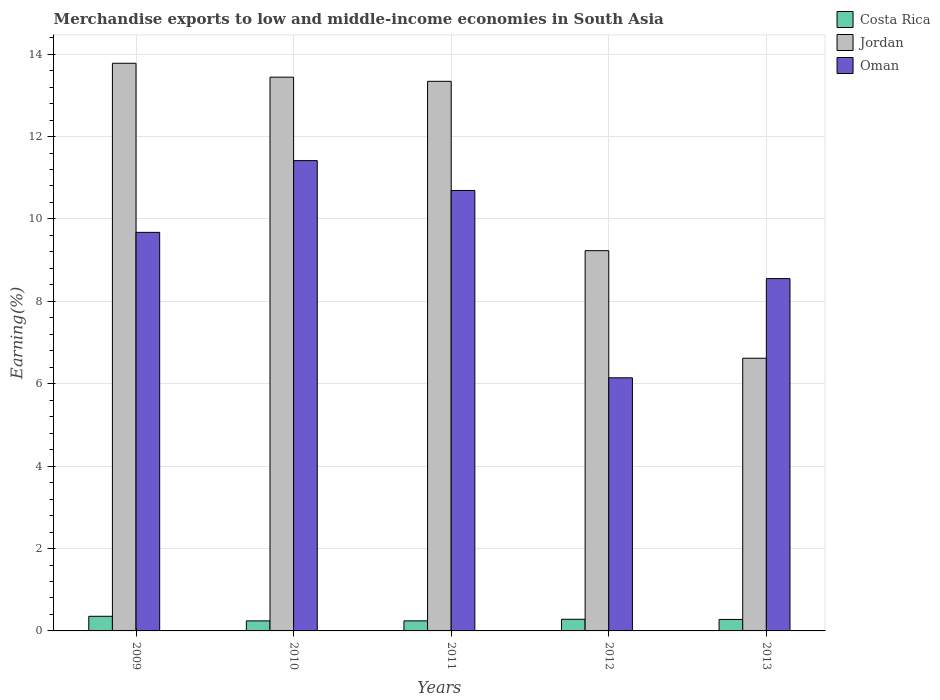How many groups of bars are there?
Provide a short and direct response. 5. Are the number of bars per tick equal to the number of legend labels?
Ensure brevity in your answer.  Yes. How many bars are there on the 1st tick from the left?
Your response must be concise. 3. What is the label of the 4th group of bars from the left?
Make the answer very short. 2012. What is the percentage of amount earned from merchandise exports in Jordan in 2010?
Provide a short and direct response. 13.44. Across all years, what is the maximum percentage of amount earned from merchandise exports in Jordan?
Keep it short and to the point. 13.78. Across all years, what is the minimum percentage of amount earned from merchandise exports in Jordan?
Ensure brevity in your answer.  6.62. In which year was the percentage of amount earned from merchandise exports in Jordan minimum?
Provide a succinct answer. 2013. What is the total percentage of amount earned from merchandise exports in Costa Rica in the graph?
Offer a very short reply. 1.4. What is the difference between the percentage of amount earned from merchandise exports in Oman in 2009 and that in 2012?
Provide a short and direct response. 3.53. What is the difference between the percentage of amount earned from merchandise exports in Oman in 2012 and the percentage of amount earned from merchandise exports in Costa Rica in 2013?
Your answer should be compact. 5.87. What is the average percentage of amount earned from merchandise exports in Jordan per year?
Give a very brief answer. 11.28. In the year 2009, what is the difference between the percentage of amount earned from merchandise exports in Costa Rica and percentage of amount earned from merchandise exports in Jordan?
Give a very brief answer. -13.42. In how many years, is the percentage of amount earned from merchandise exports in Jordan greater than 8.8 %?
Your answer should be compact. 4. What is the ratio of the percentage of amount earned from merchandise exports in Costa Rica in 2010 to that in 2012?
Provide a succinct answer. 0.86. Is the difference between the percentage of amount earned from merchandise exports in Costa Rica in 2009 and 2012 greater than the difference between the percentage of amount earned from merchandise exports in Jordan in 2009 and 2012?
Provide a succinct answer. No. What is the difference between the highest and the second highest percentage of amount earned from merchandise exports in Costa Rica?
Offer a terse response. 0.07. What is the difference between the highest and the lowest percentage of amount earned from merchandise exports in Oman?
Your answer should be very brief. 5.27. What does the 2nd bar from the left in 2012 represents?
Your answer should be compact. Jordan. What does the 2nd bar from the right in 2010 represents?
Your answer should be very brief. Jordan. Are all the bars in the graph horizontal?
Provide a short and direct response. No. How many years are there in the graph?
Keep it short and to the point. 5. Are the values on the major ticks of Y-axis written in scientific E-notation?
Your answer should be very brief. No. Does the graph contain any zero values?
Make the answer very short. No. How many legend labels are there?
Keep it short and to the point. 3. How are the legend labels stacked?
Your answer should be very brief. Vertical. What is the title of the graph?
Offer a very short reply. Merchandise exports to low and middle-income economies in South Asia. What is the label or title of the X-axis?
Your answer should be compact. Years. What is the label or title of the Y-axis?
Ensure brevity in your answer.  Earning(%). What is the Earning(%) of Costa Rica in 2009?
Provide a short and direct response. 0.36. What is the Earning(%) of Jordan in 2009?
Offer a terse response. 13.78. What is the Earning(%) in Oman in 2009?
Your answer should be compact. 9.67. What is the Earning(%) in Costa Rica in 2010?
Offer a very short reply. 0.24. What is the Earning(%) in Jordan in 2010?
Your answer should be compact. 13.44. What is the Earning(%) of Oman in 2010?
Give a very brief answer. 11.42. What is the Earning(%) of Costa Rica in 2011?
Offer a terse response. 0.24. What is the Earning(%) of Jordan in 2011?
Your response must be concise. 13.34. What is the Earning(%) of Oman in 2011?
Offer a very short reply. 10.69. What is the Earning(%) in Costa Rica in 2012?
Offer a very short reply. 0.28. What is the Earning(%) in Jordan in 2012?
Ensure brevity in your answer.  9.23. What is the Earning(%) in Oman in 2012?
Your answer should be very brief. 6.14. What is the Earning(%) in Costa Rica in 2013?
Keep it short and to the point. 0.28. What is the Earning(%) of Jordan in 2013?
Keep it short and to the point. 6.62. What is the Earning(%) in Oman in 2013?
Give a very brief answer. 8.55. Across all years, what is the maximum Earning(%) of Costa Rica?
Keep it short and to the point. 0.36. Across all years, what is the maximum Earning(%) of Jordan?
Your answer should be compact. 13.78. Across all years, what is the maximum Earning(%) of Oman?
Your answer should be very brief. 11.42. Across all years, what is the minimum Earning(%) of Costa Rica?
Your answer should be very brief. 0.24. Across all years, what is the minimum Earning(%) in Jordan?
Offer a terse response. 6.62. Across all years, what is the minimum Earning(%) in Oman?
Your answer should be very brief. 6.14. What is the total Earning(%) in Costa Rica in the graph?
Make the answer very short. 1.4. What is the total Earning(%) in Jordan in the graph?
Ensure brevity in your answer.  56.41. What is the total Earning(%) in Oman in the graph?
Your answer should be very brief. 46.48. What is the difference between the Earning(%) of Costa Rica in 2009 and that in 2010?
Provide a succinct answer. 0.11. What is the difference between the Earning(%) in Jordan in 2009 and that in 2010?
Your response must be concise. 0.34. What is the difference between the Earning(%) of Oman in 2009 and that in 2010?
Your answer should be very brief. -1.74. What is the difference between the Earning(%) of Costa Rica in 2009 and that in 2011?
Your answer should be compact. 0.11. What is the difference between the Earning(%) in Jordan in 2009 and that in 2011?
Keep it short and to the point. 0.44. What is the difference between the Earning(%) of Oman in 2009 and that in 2011?
Your answer should be compact. -1.02. What is the difference between the Earning(%) of Costa Rica in 2009 and that in 2012?
Your answer should be very brief. 0.07. What is the difference between the Earning(%) in Jordan in 2009 and that in 2012?
Give a very brief answer. 4.55. What is the difference between the Earning(%) of Oman in 2009 and that in 2012?
Your response must be concise. 3.53. What is the difference between the Earning(%) of Costa Rica in 2009 and that in 2013?
Ensure brevity in your answer.  0.08. What is the difference between the Earning(%) of Jordan in 2009 and that in 2013?
Offer a very short reply. 7.16. What is the difference between the Earning(%) in Oman in 2009 and that in 2013?
Offer a very short reply. 1.12. What is the difference between the Earning(%) of Costa Rica in 2010 and that in 2011?
Make the answer very short. -0. What is the difference between the Earning(%) in Jordan in 2010 and that in 2011?
Your answer should be very brief. 0.1. What is the difference between the Earning(%) in Oman in 2010 and that in 2011?
Make the answer very short. 0.72. What is the difference between the Earning(%) in Costa Rica in 2010 and that in 2012?
Provide a short and direct response. -0.04. What is the difference between the Earning(%) in Jordan in 2010 and that in 2012?
Keep it short and to the point. 4.21. What is the difference between the Earning(%) of Oman in 2010 and that in 2012?
Give a very brief answer. 5.27. What is the difference between the Earning(%) of Costa Rica in 2010 and that in 2013?
Your answer should be compact. -0.04. What is the difference between the Earning(%) of Jordan in 2010 and that in 2013?
Make the answer very short. 6.82. What is the difference between the Earning(%) in Oman in 2010 and that in 2013?
Your response must be concise. 2.86. What is the difference between the Earning(%) of Costa Rica in 2011 and that in 2012?
Provide a short and direct response. -0.04. What is the difference between the Earning(%) of Jordan in 2011 and that in 2012?
Make the answer very short. 4.11. What is the difference between the Earning(%) of Oman in 2011 and that in 2012?
Provide a succinct answer. 4.55. What is the difference between the Earning(%) in Costa Rica in 2011 and that in 2013?
Give a very brief answer. -0.03. What is the difference between the Earning(%) of Jordan in 2011 and that in 2013?
Give a very brief answer. 6.72. What is the difference between the Earning(%) in Oman in 2011 and that in 2013?
Provide a succinct answer. 2.14. What is the difference between the Earning(%) in Costa Rica in 2012 and that in 2013?
Offer a terse response. 0. What is the difference between the Earning(%) in Jordan in 2012 and that in 2013?
Keep it short and to the point. 2.61. What is the difference between the Earning(%) of Oman in 2012 and that in 2013?
Give a very brief answer. -2.41. What is the difference between the Earning(%) in Costa Rica in 2009 and the Earning(%) in Jordan in 2010?
Your answer should be very brief. -13.09. What is the difference between the Earning(%) of Costa Rica in 2009 and the Earning(%) of Oman in 2010?
Make the answer very short. -11.06. What is the difference between the Earning(%) in Jordan in 2009 and the Earning(%) in Oman in 2010?
Your response must be concise. 2.36. What is the difference between the Earning(%) of Costa Rica in 2009 and the Earning(%) of Jordan in 2011?
Make the answer very short. -12.99. What is the difference between the Earning(%) of Costa Rica in 2009 and the Earning(%) of Oman in 2011?
Give a very brief answer. -10.34. What is the difference between the Earning(%) of Jordan in 2009 and the Earning(%) of Oman in 2011?
Offer a terse response. 3.09. What is the difference between the Earning(%) of Costa Rica in 2009 and the Earning(%) of Jordan in 2012?
Provide a short and direct response. -8.87. What is the difference between the Earning(%) of Costa Rica in 2009 and the Earning(%) of Oman in 2012?
Ensure brevity in your answer.  -5.79. What is the difference between the Earning(%) in Jordan in 2009 and the Earning(%) in Oman in 2012?
Give a very brief answer. 7.64. What is the difference between the Earning(%) of Costa Rica in 2009 and the Earning(%) of Jordan in 2013?
Ensure brevity in your answer.  -6.26. What is the difference between the Earning(%) in Costa Rica in 2009 and the Earning(%) in Oman in 2013?
Give a very brief answer. -8.2. What is the difference between the Earning(%) in Jordan in 2009 and the Earning(%) in Oman in 2013?
Provide a succinct answer. 5.23. What is the difference between the Earning(%) in Costa Rica in 2010 and the Earning(%) in Jordan in 2011?
Ensure brevity in your answer.  -13.1. What is the difference between the Earning(%) in Costa Rica in 2010 and the Earning(%) in Oman in 2011?
Your response must be concise. -10.45. What is the difference between the Earning(%) in Jordan in 2010 and the Earning(%) in Oman in 2011?
Your answer should be compact. 2.75. What is the difference between the Earning(%) of Costa Rica in 2010 and the Earning(%) of Jordan in 2012?
Your answer should be compact. -8.99. What is the difference between the Earning(%) of Costa Rica in 2010 and the Earning(%) of Oman in 2012?
Give a very brief answer. -5.9. What is the difference between the Earning(%) of Jordan in 2010 and the Earning(%) of Oman in 2012?
Your answer should be compact. 7.3. What is the difference between the Earning(%) of Costa Rica in 2010 and the Earning(%) of Jordan in 2013?
Provide a short and direct response. -6.38. What is the difference between the Earning(%) in Costa Rica in 2010 and the Earning(%) in Oman in 2013?
Give a very brief answer. -8.31. What is the difference between the Earning(%) of Jordan in 2010 and the Earning(%) of Oman in 2013?
Your answer should be compact. 4.89. What is the difference between the Earning(%) in Costa Rica in 2011 and the Earning(%) in Jordan in 2012?
Offer a terse response. -8.99. What is the difference between the Earning(%) of Costa Rica in 2011 and the Earning(%) of Oman in 2012?
Ensure brevity in your answer.  -5.9. What is the difference between the Earning(%) in Jordan in 2011 and the Earning(%) in Oman in 2012?
Provide a succinct answer. 7.2. What is the difference between the Earning(%) in Costa Rica in 2011 and the Earning(%) in Jordan in 2013?
Offer a terse response. -6.38. What is the difference between the Earning(%) of Costa Rica in 2011 and the Earning(%) of Oman in 2013?
Keep it short and to the point. -8.31. What is the difference between the Earning(%) in Jordan in 2011 and the Earning(%) in Oman in 2013?
Provide a short and direct response. 4.79. What is the difference between the Earning(%) of Costa Rica in 2012 and the Earning(%) of Jordan in 2013?
Give a very brief answer. -6.34. What is the difference between the Earning(%) in Costa Rica in 2012 and the Earning(%) in Oman in 2013?
Provide a short and direct response. -8.27. What is the difference between the Earning(%) of Jordan in 2012 and the Earning(%) of Oman in 2013?
Your response must be concise. 0.68. What is the average Earning(%) of Costa Rica per year?
Make the answer very short. 0.28. What is the average Earning(%) in Jordan per year?
Provide a short and direct response. 11.28. What is the average Earning(%) of Oman per year?
Provide a succinct answer. 9.3. In the year 2009, what is the difference between the Earning(%) of Costa Rica and Earning(%) of Jordan?
Your answer should be very brief. -13.42. In the year 2009, what is the difference between the Earning(%) in Costa Rica and Earning(%) in Oman?
Keep it short and to the point. -9.32. In the year 2009, what is the difference between the Earning(%) of Jordan and Earning(%) of Oman?
Your response must be concise. 4.1. In the year 2010, what is the difference between the Earning(%) of Costa Rica and Earning(%) of Jordan?
Ensure brevity in your answer.  -13.2. In the year 2010, what is the difference between the Earning(%) in Costa Rica and Earning(%) in Oman?
Make the answer very short. -11.17. In the year 2010, what is the difference between the Earning(%) in Jordan and Earning(%) in Oman?
Offer a terse response. 2.03. In the year 2011, what is the difference between the Earning(%) in Costa Rica and Earning(%) in Jordan?
Offer a terse response. -13.1. In the year 2011, what is the difference between the Earning(%) in Costa Rica and Earning(%) in Oman?
Your answer should be compact. -10.45. In the year 2011, what is the difference between the Earning(%) in Jordan and Earning(%) in Oman?
Offer a terse response. 2.65. In the year 2012, what is the difference between the Earning(%) in Costa Rica and Earning(%) in Jordan?
Give a very brief answer. -8.95. In the year 2012, what is the difference between the Earning(%) of Costa Rica and Earning(%) of Oman?
Your answer should be compact. -5.86. In the year 2012, what is the difference between the Earning(%) in Jordan and Earning(%) in Oman?
Keep it short and to the point. 3.09. In the year 2013, what is the difference between the Earning(%) in Costa Rica and Earning(%) in Jordan?
Your response must be concise. -6.34. In the year 2013, what is the difference between the Earning(%) in Costa Rica and Earning(%) in Oman?
Your answer should be very brief. -8.27. In the year 2013, what is the difference between the Earning(%) of Jordan and Earning(%) of Oman?
Your answer should be compact. -1.93. What is the ratio of the Earning(%) in Costa Rica in 2009 to that in 2010?
Offer a very short reply. 1.46. What is the ratio of the Earning(%) of Jordan in 2009 to that in 2010?
Offer a very short reply. 1.03. What is the ratio of the Earning(%) of Oman in 2009 to that in 2010?
Your answer should be very brief. 0.85. What is the ratio of the Earning(%) in Costa Rica in 2009 to that in 2011?
Make the answer very short. 1.46. What is the ratio of the Earning(%) in Jordan in 2009 to that in 2011?
Your answer should be compact. 1.03. What is the ratio of the Earning(%) of Oman in 2009 to that in 2011?
Offer a terse response. 0.9. What is the ratio of the Earning(%) in Costa Rica in 2009 to that in 2012?
Offer a very short reply. 1.26. What is the ratio of the Earning(%) of Jordan in 2009 to that in 2012?
Offer a very short reply. 1.49. What is the ratio of the Earning(%) of Oman in 2009 to that in 2012?
Keep it short and to the point. 1.57. What is the ratio of the Earning(%) of Costa Rica in 2009 to that in 2013?
Your answer should be compact. 1.28. What is the ratio of the Earning(%) of Jordan in 2009 to that in 2013?
Your response must be concise. 2.08. What is the ratio of the Earning(%) in Oman in 2009 to that in 2013?
Provide a succinct answer. 1.13. What is the ratio of the Earning(%) in Costa Rica in 2010 to that in 2011?
Your answer should be very brief. 1. What is the ratio of the Earning(%) in Jordan in 2010 to that in 2011?
Provide a succinct answer. 1.01. What is the ratio of the Earning(%) of Oman in 2010 to that in 2011?
Offer a terse response. 1.07. What is the ratio of the Earning(%) of Costa Rica in 2010 to that in 2012?
Offer a terse response. 0.86. What is the ratio of the Earning(%) of Jordan in 2010 to that in 2012?
Provide a short and direct response. 1.46. What is the ratio of the Earning(%) in Oman in 2010 to that in 2012?
Your answer should be compact. 1.86. What is the ratio of the Earning(%) in Costa Rica in 2010 to that in 2013?
Make the answer very short. 0.87. What is the ratio of the Earning(%) in Jordan in 2010 to that in 2013?
Give a very brief answer. 2.03. What is the ratio of the Earning(%) of Oman in 2010 to that in 2013?
Provide a succinct answer. 1.33. What is the ratio of the Earning(%) of Costa Rica in 2011 to that in 2012?
Ensure brevity in your answer.  0.86. What is the ratio of the Earning(%) in Jordan in 2011 to that in 2012?
Your answer should be very brief. 1.45. What is the ratio of the Earning(%) in Oman in 2011 to that in 2012?
Give a very brief answer. 1.74. What is the ratio of the Earning(%) of Costa Rica in 2011 to that in 2013?
Provide a short and direct response. 0.88. What is the ratio of the Earning(%) of Jordan in 2011 to that in 2013?
Your answer should be very brief. 2.02. What is the ratio of the Earning(%) in Oman in 2011 to that in 2013?
Provide a short and direct response. 1.25. What is the ratio of the Earning(%) in Costa Rica in 2012 to that in 2013?
Offer a very short reply. 1.02. What is the ratio of the Earning(%) in Jordan in 2012 to that in 2013?
Offer a very short reply. 1.39. What is the ratio of the Earning(%) of Oman in 2012 to that in 2013?
Provide a succinct answer. 0.72. What is the difference between the highest and the second highest Earning(%) of Costa Rica?
Keep it short and to the point. 0.07. What is the difference between the highest and the second highest Earning(%) in Jordan?
Give a very brief answer. 0.34. What is the difference between the highest and the second highest Earning(%) of Oman?
Make the answer very short. 0.72. What is the difference between the highest and the lowest Earning(%) of Costa Rica?
Ensure brevity in your answer.  0.11. What is the difference between the highest and the lowest Earning(%) in Jordan?
Your response must be concise. 7.16. What is the difference between the highest and the lowest Earning(%) of Oman?
Provide a short and direct response. 5.27. 